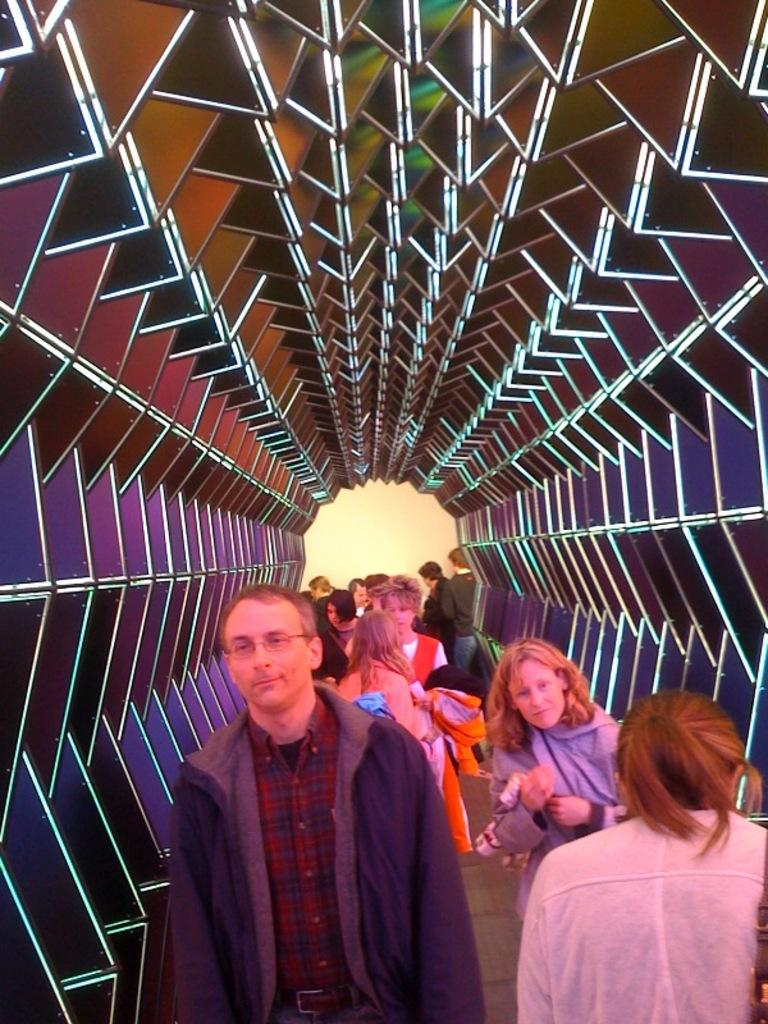Who or what is present in the image? There are people in the image. What are the people wearing? The people are wearing different color dresses. What can be seen in the background of the image? The background of the image has multiple colors. How many babies are present in the image? There is no mention of babies in the image, so we cannot determine their presence or number. 